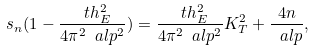<formula> <loc_0><loc_0><loc_500><loc_500>s _ { n } ( 1 - \frac { \ t h _ { E } ^ { 2 } } { 4 \pi ^ { 2 } \ a l p ^ { 2 } } ) = \frac { \ t h _ { E } ^ { 2 } } { 4 \pi ^ { 2 } \ a l p ^ { 2 } } K _ { T } ^ { 2 } + \frac { 4 n } { \ a l p } ,</formula> 